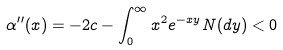Convert formula to latex. <formula><loc_0><loc_0><loc_500><loc_500>\alpha ^ { \prime \prime } ( x ) & = - 2 c - \int _ { 0 } ^ { \infty } x ^ { 2 } e ^ { - x y } N ( d y ) < 0</formula> 